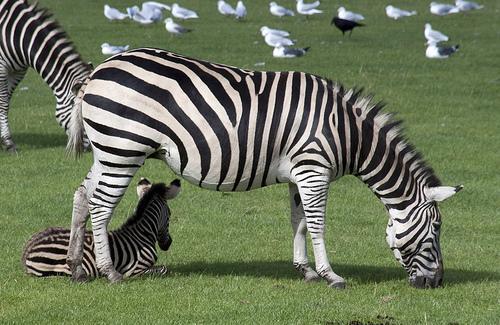How many zebras are there?
Give a very brief answer. 3. 